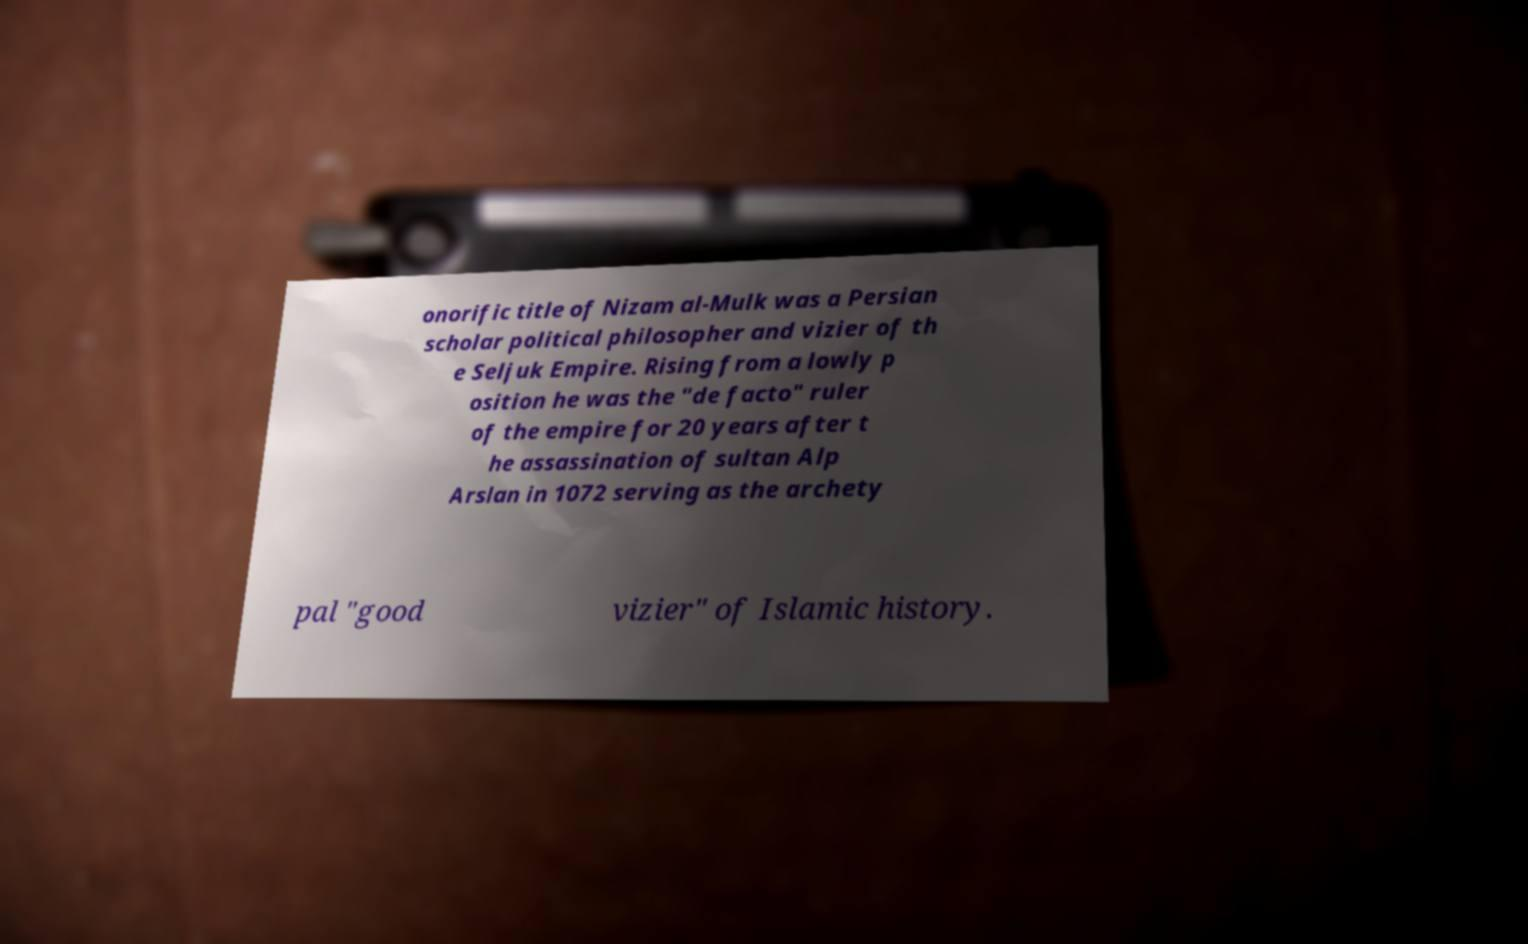Can you read and provide the text displayed in the image?This photo seems to have some interesting text. Can you extract and type it out for me? onorific title of Nizam al-Mulk was a Persian scholar political philosopher and vizier of th e Seljuk Empire. Rising from a lowly p osition he was the "de facto" ruler of the empire for 20 years after t he assassination of sultan Alp Arslan in 1072 serving as the archety pal "good vizier" of Islamic history. 